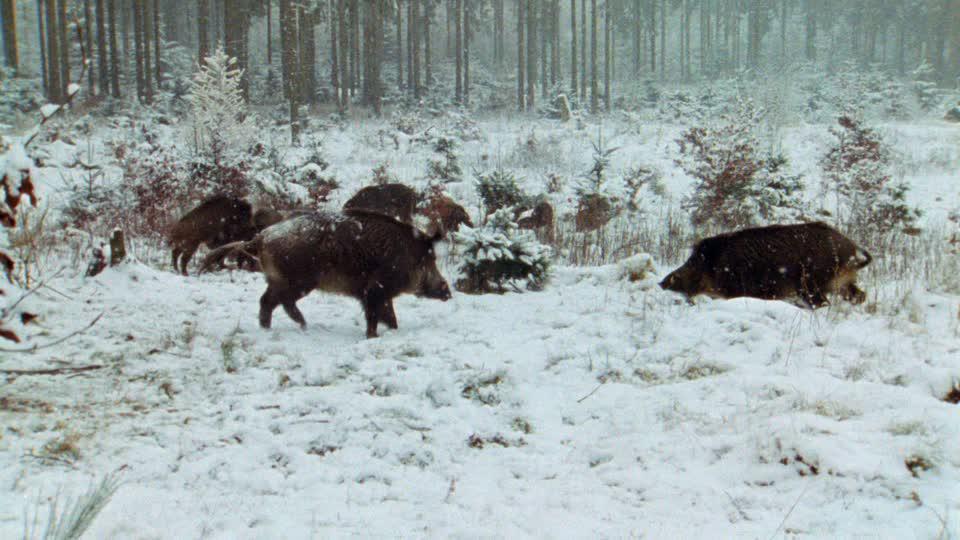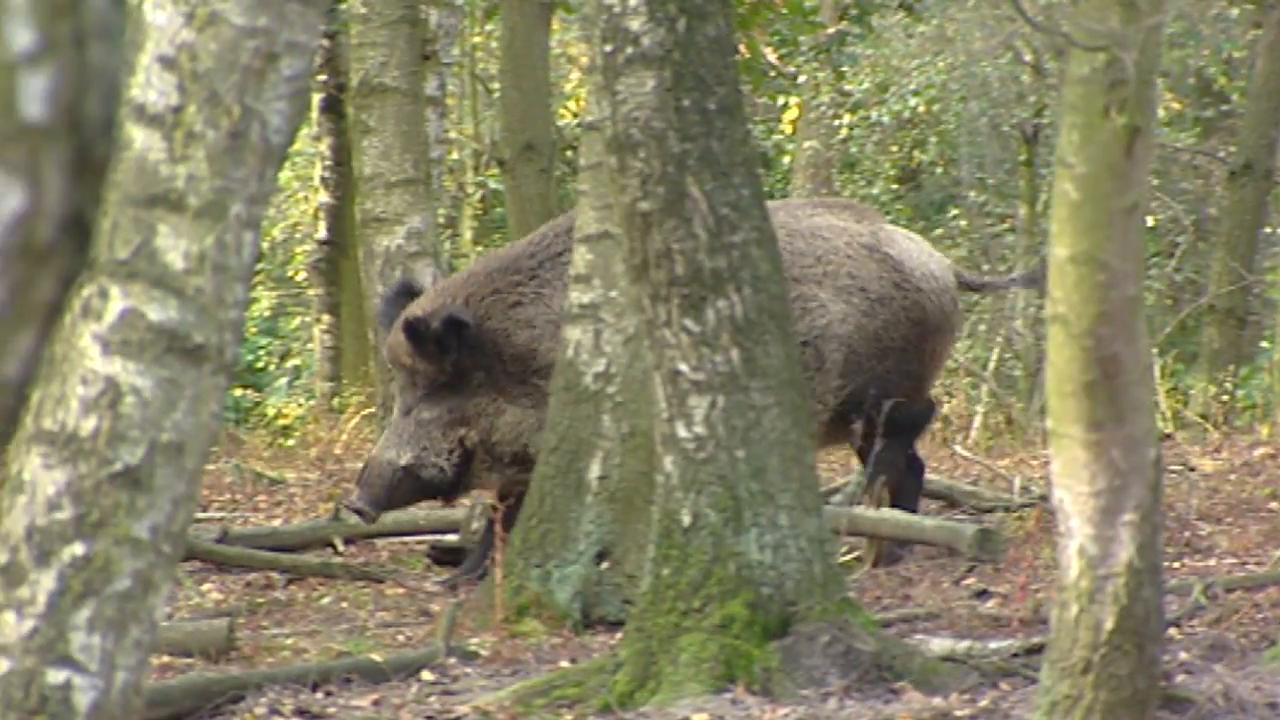The first image is the image on the left, the second image is the image on the right. Analyze the images presented: Is the assertion "There are no more than 2 wild pigs." valid? Answer yes or no. No. The first image is the image on the left, the second image is the image on the right. Analyze the images presented: Is the assertion "there are two warthogs in the image pair" valid? Answer yes or no. No. 